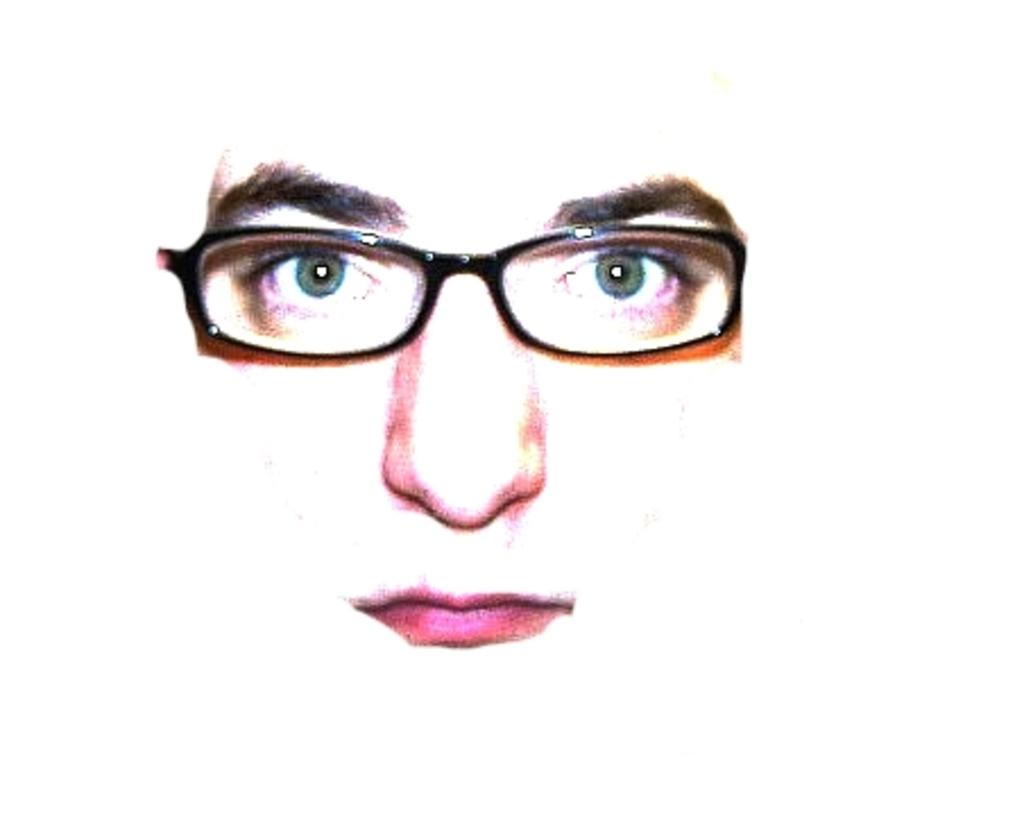What facial features can be seen in the image? Human eyes, eyebrows, a nose, and lips can be seen in the image. What accessory is present in the image? There are glasses in the image. What type of leather is used to make the school bag in the image? There is no school bag or leather present in the image; it only features facial features and glasses. 